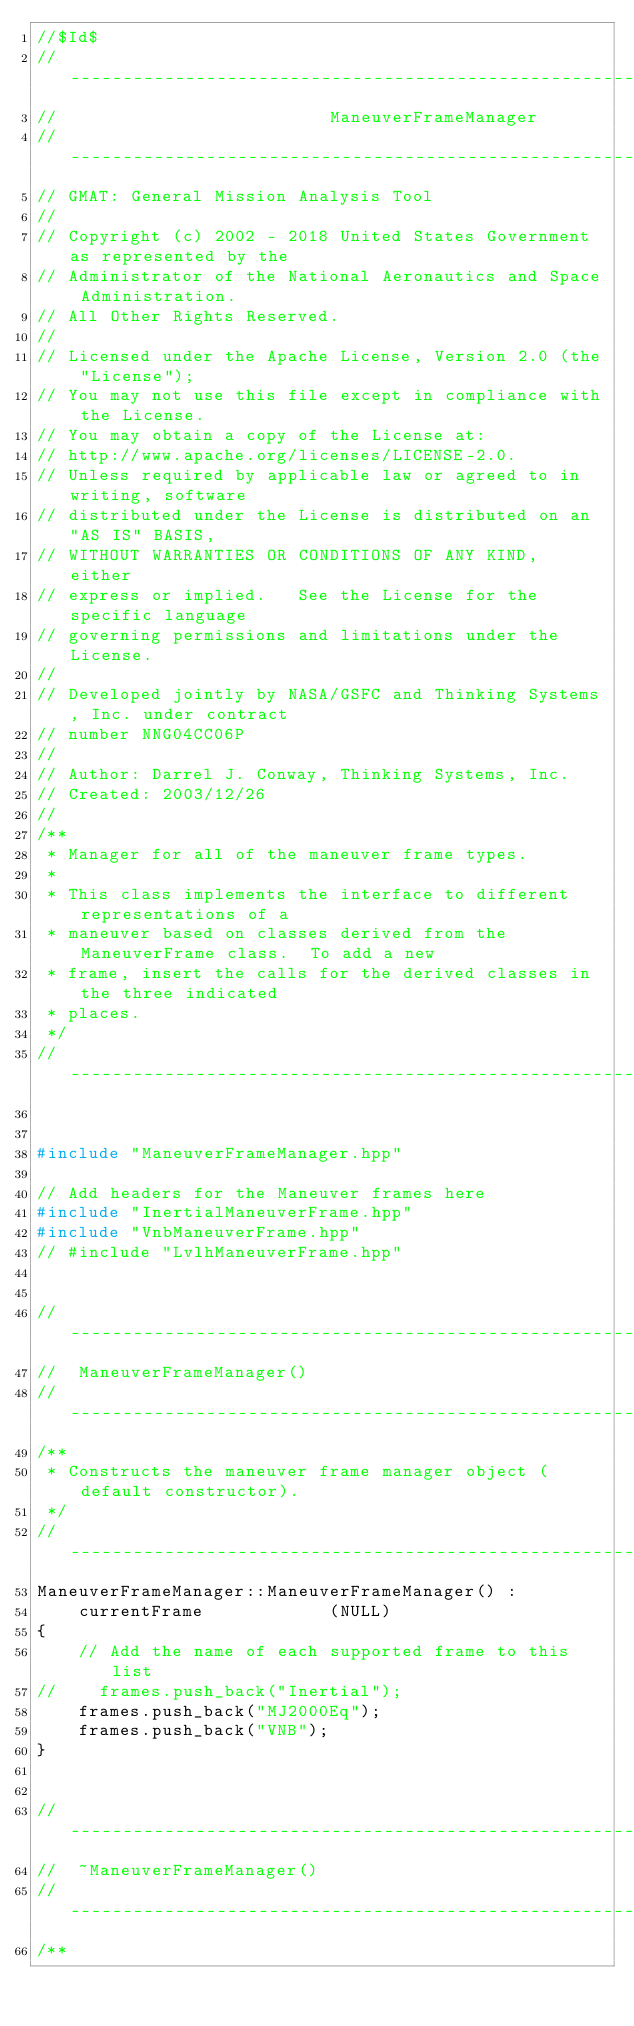<code> <loc_0><loc_0><loc_500><loc_500><_C++_>//$Id$
//------------------------------------------------------------------------------
//                          ManeuverFrameManager
//------------------------------------------------------------------------------
// GMAT: General Mission Analysis Tool
//
// Copyright (c) 2002 - 2018 United States Government as represented by the
// Administrator of the National Aeronautics and Space Administration.
// All Other Rights Reserved.
//
// Licensed under the Apache License, Version 2.0 (the "License"); 
// You may not use this file except in compliance with the License. 
// You may obtain a copy of the License at:
// http://www.apache.org/licenses/LICENSE-2.0. 
// Unless required by applicable law or agreed to in writing, software
// distributed under the License is distributed on an "AS IS" BASIS,
// WITHOUT WARRANTIES OR CONDITIONS OF ANY KIND, either 
// express or implied.   See the License for the specific language
// governing permissions and limitations under the License.
//
// Developed jointly by NASA/GSFC and Thinking Systems, Inc. under contract
// number NNG04CC06P
//
// Author: Darrel J. Conway, Thinking Systems, Inc.
// Created: 2003/12/26
//
/**
 * Manager for all of the maneuver frame types. 
 * 
 * This class implements the interface to different representations of a 
 * maneuver based on classes derived from the ManeuverFrame class.  To add a new
 * frame, insert the calls for the derived classes in the three indicated 
 * places.
 */
//------------------------------------------------------------------------------


#include "ManeuverFrameManager.hpp"

// Add headers for the Maneuver frames here
#include "InertialManeuverFrame.hpp"
#include "VnbManeuverFrame.hpp"
// #include "LvlhManeuverFrame.hpp"


//------------------------------------------------------------------------------
//  ManeuverFrameManager()
//------------------------------------------------------------------------------
/**
 * Constructs the maneuver frame manager object (default constructor).
 */
//------------------------------------------------------------------------------
ManeuverFrameManager::ManeuverFrameManager() :
    currentFrame            (NULL)
{
    // Add the name of each supported frame to this list
//    frames.push_back("Inertial");
    frames.push_back("MJ2000Eq");
    frames.push_back("VNB");
}


//------------------------------------------------------------------------------
//  ~ManeuverFrameManager()
//------------------------------------------------------------------------------
/**</code> 